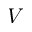Convert formula to latex. <formula><loc_0><loc_0><loc_500><loc_500>V</formula> 